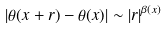Convert formula to latex. <formula><loc_0><loc_0><loc_500><loc_500>| \theta ( x + r ) - \theta ( x ) | \sim | r | ^ { \beta ( x ) }</formula> 